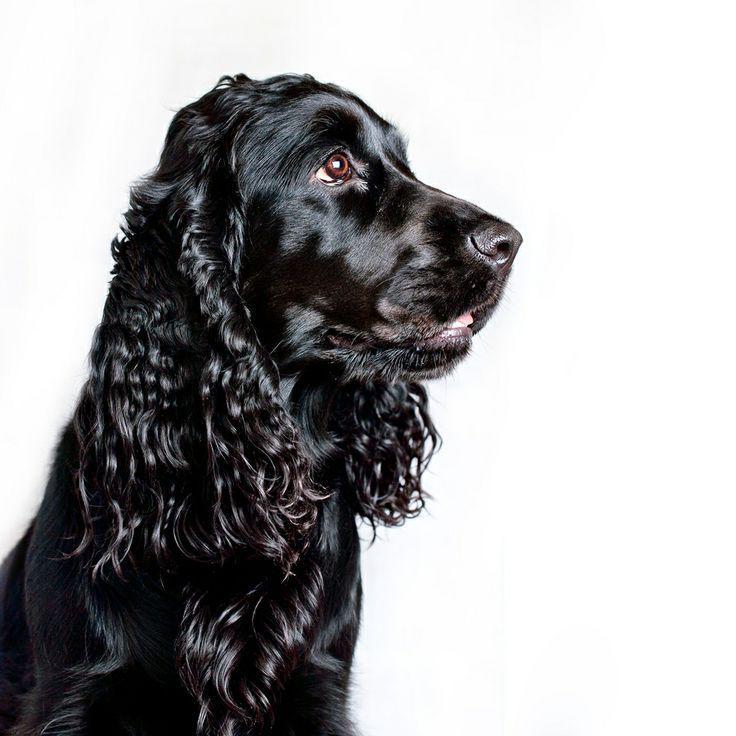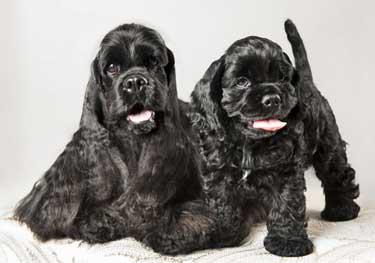The first image is the image on the left, the second image is the image on the right. Assess this claim about the two images: "There are no less than three dogs visible". Correct or not? Answer yes or no. Yes. 